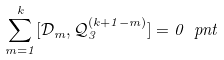Convert formula to latex. <formula><loc_0><loc_0><loc_500><loc_500>\sum _ { m = 1 } ^ { k } [ \mathcal { D } _ { m } , \mathcal { Q } _ { 3 } ^ { ( k + 1 - m ) } ] = 0 \ p n t</formula> 